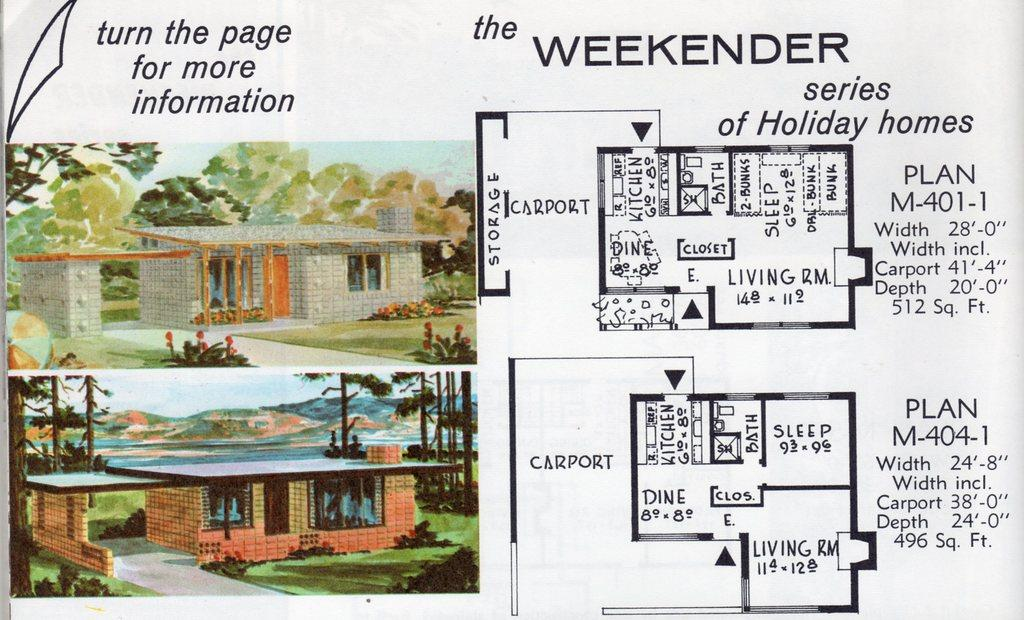<image>
Summarize the visual content of the image. the word weekender is on the white and black sheet 